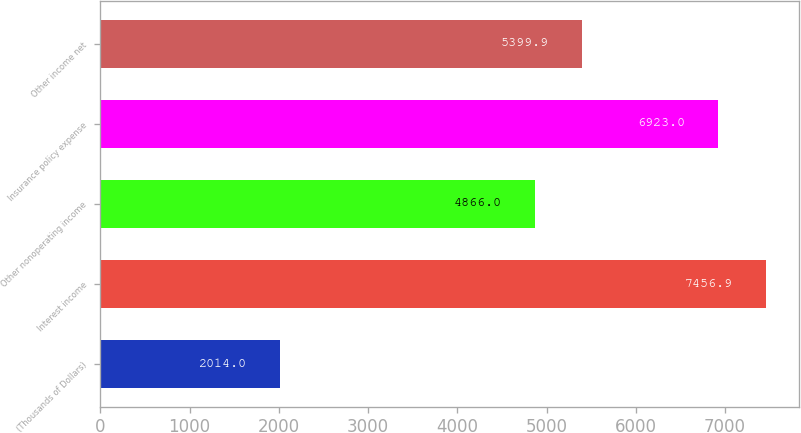<chart> <loc_0><loc_0><loc_500><loc_500><bar_chart><fcel>(Thousands of Dollars)<fcel>Interest income<fcel>Other nonoperating income<fcel>Insurance policy expense<fcel>Other income net<nl><fcel>2014<fcel>7456.9<fcel>4866<fcel>6923<fcel>5399.9<nl></chart> 